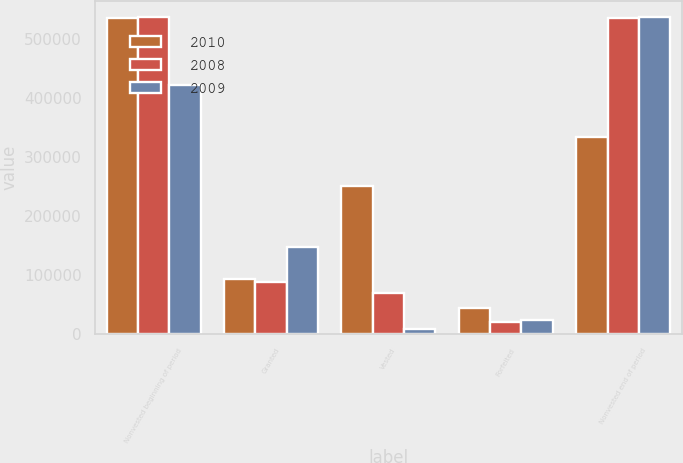Convert chart to OTSL. <chart><loc_0><loc_0><loc_500><loc_500><stacked_bar_chart><ecel><fcel>Nonvested beginning of period<fcel>Granted<fcel>Vested<fcel>Forfeited<fcel>Nonvested end of period<nl><fcel>2010<fcel>535625<fcel>92750<fcel>250126<fcel>44833<fcel>333416<nl><fcel>2008<fcel>536700<fcel>88625<fcel>69700<fcel>20000<fcel>535625<nl><fcel>2009<fcel>421500<fcel>147200<fcel>8000<fcel>24000<fcel>536700<nl></chart> 